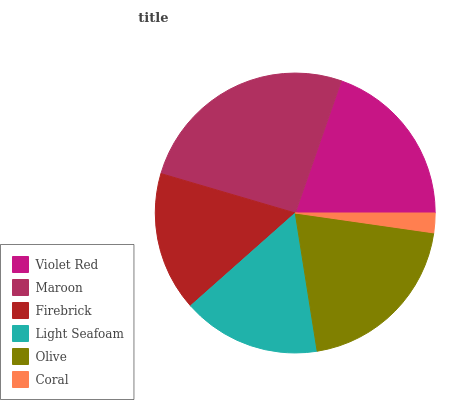Is Coral the minimum?
Answer yes or no. Yes. Is Maroon the maximum?
Answer yes or no. Yes. Is Firebrick the minimum?
Answer yes or no. No. Is Firebrick the maximum?
Answer yes or no. No. Is Maroon greater than Firebrick?
Answer yes or no. Yes. Is Firebrick less than Maroon?
Answer yes or no. Yes. Is Firebrick greater than Maroon?
Answer yes or no. No. Is Maroon less than Firebrick?
Answer yes or no. No. Is Violet Red the high median?
Answer yes or no. Yes. Is Firebrick the low median?
Answer yes or no. Yes. Is Light Seafoam the high median?
Answer yes or no. No. Is Coral the low median?
Answer yes or no. No. 